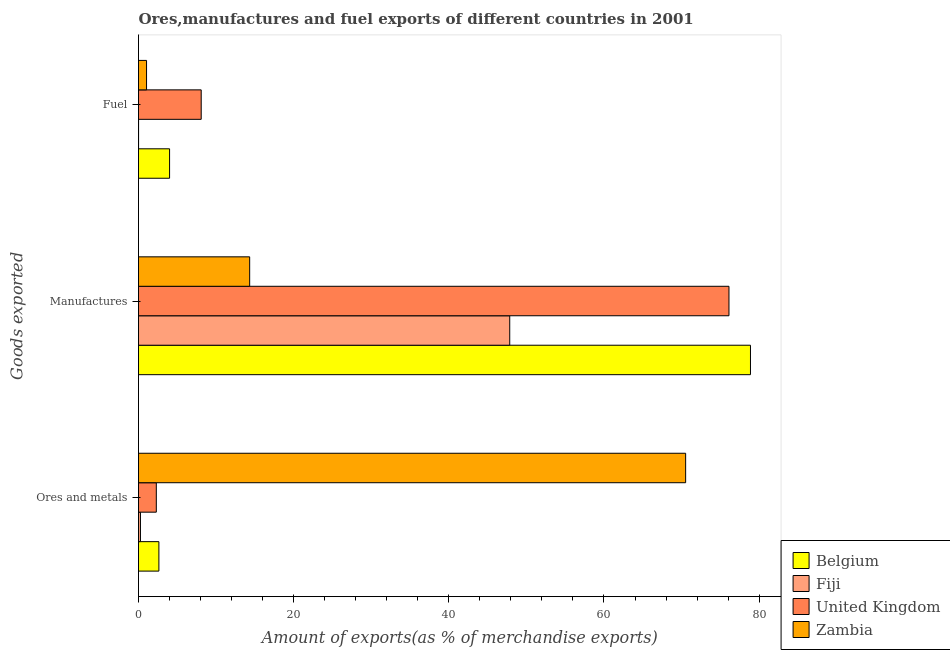How many bars are there on the 2nd tick from the bottom?
Your answer should be very brief. 4. What is the label of the 1st group of bars from the top?
Provide a succinct answer. Fuel. What is the percentage of fuel exports in Fiji?
Make the answer very short. 0.01. Across all countries, what is the maximum percentage of ores and metals exports?
Provide a succinct answer. 70.53. Across all countries, what is the minimum percentage of manufactures exports?
Offer a very short reply. 14.33. In which country was the percentage of manufactures exports minimum?
Ensure brevity in your answer.  Zambia. What is the total percentage of fuel exports in the graph?
Ensure brevity in your answer.  13.13. What is the difference between the percentage of fuel exports in United Kingdom and that in Zambia?
Keep it short and to the point. 7.04. What is the difference between the percentage of manufactures exports in Fiji and the percentage of ores and metals exports in United Kingdom?
Offer a terse response. 45.56. What is the average percentage of ores and metals exports per country?
Ensure brevity in your answer.  18.93. What is the difference between the percentage of manufactures exports and percentage of fuel exports in United Kingdom?
Give a very brief answer. 68.03. What is the ratio of the percentage of ores and metals exports in United Kingdom to that in Belgium?
Provide a short and direct response. 0.87. Is the percentage of ores and metals exports in United Kingdom less than that in Zambia?
Your answer should be very brief. Yes. Is the difference between the percentage of manufactures exports in Fiji and Zambia greater than the difference between the percentage of ores and metals exports in Fiji and Zambia?
Your answer should be very brief. Yes. What is the difference between the highest and the second highest percentage of fuel exports?
Offer a very short reply. 4.08. What is the difference between the highest and the lowest percentage of fuel exports?
Provide a short and direct response. 8.08. What does the 3rd bar from the bottom in Ores and metals represents?
Offer a very short reply. United Kingdom. Is it the case that in every country, the sum of the percentage of ores and metals exports and percentage of manufactures exports is greater than the percentage of fuel exports?
Make the answer very short. Yes. Are all the bars in the graph horizontal?
Make the answer very short. Yes. How many countries are there in the graph?
Your answer should be very brief. 4. Does the graph contain any zero values?
Offer a terse response. No. Does the graph contain grids?
Provide a succinct answer. No. How many legend labels are there?
Offer a terse response. 4. What is the title of the graph?
Make the answer very short. Ores,manufactures and fuel exports of different countries in 2001. Does "Spain" appear as one of the legend labels in the graph?
Ensure brevity in your answer.  No. What is the label or title of the X-axis?
Your response must be concise. Amount of exports(as % of merchandise exports). What is the label or title of the Y-axis?
Make the answer very short. Goods exported. What is the Amount of exports(as % of merchandise exports) of Belgium in Ores and metals?
Your answer should be compact. 2.63. What is the Amount of exports(as % of merchandise exports) in Fiji in Ores and metals?
Provide a short and direct response. 0.25. What is the Amount of exports(as % of merchandise exports) in United Kingdom in Ores and metals?
Offer a very short reply. 2.29. What is the Amount of exports(as % of merchandise exports) in Zambia in Ores and metals?
Your answer should be very brief. 70.53. What is the Amount of exports(as % of merchandise exports) of Belgium in Manufactures?
Your answer should be very brief. 78.88. What is the Amount of exports(as % of merchandise exports) in Fiji in Manufactures?
Your response must be concise. 47.85. What is the Amount of exports(as % of merchandise exports) in United Kingdom in Manufactures?
Ensure brevity in your answer.  76.11. What is the Amount of exports(as % of merchandise exports) in Zambia in Manufactures?
Ensure brevity in your answer.  14.33. What is the Amount of exports(as % of merchandise exports) in Belgium in Fuel?
Keep it short and to the point. 4.01. What is the Amount of exports(as % of merchandise exports) of Fiji in Fuel?
Provide a succinct answer. 0.01. What is the Amount of exports(as % of merchandise exports) of United Kingdom in Fuel?
Provide a short and direct response. 8.08. What is the Amount of exports(as % of merchandise exports) of Zambia in Fuel?
Ensure brevity in your answer.  1.04. Across all Goods exported, what is the maximum Amount of exports(as % of merchandise exports) in Belgium?
Offer a terse response. 78.88. Across all Goods exported, what is the maximum Amount of exports(as % of merchandise exports) in Fiji?
Offer a terse response. 47.85. Across all Goods exported, what is the maximum Amount of exports(as % of merchandise exports) of United Kingdom?
Provide a succinct answer. 76.11. Across all Goods exported, what is the maximum Amount of exports(as % of merchandise exports) in Zambia?
Provide a short and direct response. 70.53. Across all Goods exported, what is the minimum Amount of exports(as % of merchandise exports) in Belgium?
Make the answer very short. 2.63. Across all Goods exported, what is the minimum Amount of exports(as % of merchandise exports) in Fiji?
Your answer should be compact. 0.01. Across all Goods exported, what is the minimum Amount of exports(as % of merchandise exports) in United Kingdom?
Provide a succinct answer. 2.29. Across all Goods exported, what is the minimum Amount of exports(as % of merchandise exports) of Zambia?
Provide a succinct answer. 1.04. What is the total Amount of exports(as % of merchandise exports) of Belgium in the graph?
Offer a terse response. 85.52. What is the total Amount of exports(as % of merchandise exports) of Fiji in the graph?
Provide a succinct answer. 48.11. What is the total Amount of exports(as % of merchandise exports) in United Kingdom in the graph?
Keep it short and to the point. 86.49. What is the total Amount of exports(as % of merchandise exports) of Zambia in the graph?
Ensure brevity in your answer.  85.9. What is the difference between the Amount of exports(as % of merchandise exports) in Belgium in Ores and metals and that in Manufactures?
Ensure brevity in your answer.  -76.26. What is the difference between the Amount of exports(as % of merchandise exports) in Fiji in Ores and metals and that in Manufactures?
Provide a short and direct response. -47.6. What is the difference between the Amount of exports(as % of merchandise exports) in United Kingdom in Ores and metals and that in Manufactures?
Ensure brevity in your answer.  -73.82. What is the difference between the Amount of exports(as % of merchandise exports) in Zambia in Ores and metals and that in Manufactures?
Your answer should be very brief. 56.2. What is the difference between the Amount of exports(as % of merchandise exports) in Belgium in Ores and metals and that in Fuel?
Provide a short and direct response. -1.38. What is the difference between the Amount of exports(as % of merchandise exports) of Fiji in Ores and metals and that in Fuel?
Offer a very short reply. 0.24. What is the difference between the Amount of exports(as % of merchandise exports) of United Kingdom in Ores and metals and that in Fuel?
Make the answer very short. -5.79. What is the difference between the Amount of exports(as % of merchandise exports) of Zambia in Ores and metals and that in Fuel?
Ensure brevity in your answer.  69.49. What is the difference between the Amount of exports(as % of merchandise exports) of Belgium in Manufactures and that in Fuel?
Make the answer very short. 74.88. What is the difference between the Amount of exports(as % of merchandise exports) of Fiji in Manufactures and that in Fuel?
Offer a very short reply. 47.85. What is the difference between the Amount of exports(as % of merchandise exports) in United Kingdom in Manufactures and that in Fuel?
Provide a short and direct response. 68.03. What is the difference between the Amount of exports(as % of merchandise exports) of Zambia in Manufactures and that in Fuel?
Offer a very short reply. 13.29. What is the difference between the Amount of exports(as % of merchandise exports) in Belgium in Ores and metals and the Amount of exports(as % of merchandise exports) in Fiji in Manufactures?
Ensure brevity in your answer.  -45.23. What is the difference between the Amount of exports(as % of merchandise exports) of Belgium in Ores and metals and the Amount of exports(as % of merchandise exports) of United Kingdom in Manufactures?
Your response must be concise. -73.48. What is the difference between the Amount of exports(as % of merchandise exports) in Belgium in Ores and metals and the Amount of exports(as % of merchandise exports) in Zambia in Manufactures?
Keep it short and to the point. -11.7. What is the difference between the Amount of exports(as % of merchandise exports) of Fiji in Ores and metals and the Amount of exports(as % of merchandise exports) of United Kingdom in Manufactures?
Ensure brevity in your answer.  -75.86. What is the difference between the Amount of exports(as % of merchandise exports) in Fiji in Ores and metals and the Amount of exports(as % of merchandise exports) in Zambia in Manufactures?
Your response must be concise. -14.08. What is the difference between the Amount of exports(as % of merchandise exports) in United Kingdom in Ores and metals and the Amount of exports(as % of merchandise exports) in Zambia in Manufactures?
Your answer should be compact. -12.04. What is the difference between the Amount of exports(as % of merchandise exports) in Belgium in Ores and metals and the Amount of exports(as % of merchandise exports) in Fiji in Fuel?
Provide a succinct answer. 2.62. What is the difference between the Amount of exports(as % of merchandise exports) in Belgium in Ores and metals and the Amount of exports(as % of merchandise exports) in United Kingdom in Fuel?
Provide a short and direct response. -5.45. What is the difference between the Amount of exports(as % of merchandise exports) in Belgium in Ores and metals and the Amount of exports(as % of merchandise exports) in Zambia in Fuel?
Provide a succinct answer. 1.59. What is the difference between the Amount of exports(as % of merchandise exports) of Fiji in Ores and metals and the Amount of exports(as % of merchandise exports) of United Kingdom in Fuel?
Your response must be concise. -7.83. What is the difference between the Amount of exports(as % of merchandise exports) in Fiji in Ores and metals and the Amount of exports(as % of merchandise exports) in Zambia in Fuel?
Offer a terse response. -0.79. What is the difference between the Amount of exports(as % of merchandise exports) of United Kingdom in Ores and metals and the Amount of exports(as % of merchandise exports) of Zambia in Fuel?
Give a very brief answer. 1.26. What is the difference between the Amount of exports(as % of merchandise exports) in Belgium in Manufactures and the Amount of exports(as % of merchandise exports) in Fiji in Fuel?
Your response must be concise. 78.88. What is the difference between the Amount of exports(as % of merchandise exports) of Belgium in Manufactures and the Amount of exports(as % of merchandise exports) of United Kingdom in Fuel?
Your answer should be compact. 70.8. What is the difference between the Amount of exports(as % of merchandise exports) in Belgium in Manufactures and the Amount of exports(as % of merchandise exports) in Zambia in Fuel?
Make the answer very short. 77.85. What is the difference between the Amount of exports(as % of merchandise exports) of Fiji in Manufactures and the Amount of exports(as % of merchandise exports) of United Kingdom in Fuel?
Provide a succinct answer. 39.77. What is the difference between the Amount of exports(as % of merchandise exports) in Fiji in Manufactures and the Amount of exports(as % of merchandise exports) in Zambia in Fuel?
Your answer should be compact. 46.82. What is the difference between the Amount of exports(as % of merchandise exports) of United Kingdom in Manufactures and the Amount of exports(as % of merchandise exports) of Zambia in Fuel?
Offer a very short reply. 75.07. What is the average Amount of exports(as % of merchandise exports) of Belgium per Goods exported?
Provide a succinct answer. 28.51. What is the average Amount of exports(as % of merchandise exports) in Fiji per Goods exported?
Keep it short and to the point. 16.04. What is the average Amount of exports(as % of merchandise exports) of United Kingdom per Goods exported?
Your answer should be compact. 28.83. What is the average Amount of exports(as % of merchandise exports) of Zambia per Goods exported?
Provide a short and direct response. 28.63. What is the difference between the Amount of exports(as % of merchandise exports) of Belgium and Amount of exports(as % of merchandise exports) of Fiji in Ores and metals?
Keep it short and to the point. 2.38. What is the difference between the Amount of exports(as % of merchandise exports) in Belgium and Amount of exports(as % of merchandise exports) in United Kingdom in Ores and metals?
Give a very brief answer. 0.33. What is the difference between the Amount of exports(as % of merchandise exports) in Belgium and Amount of exports(as % of merchandise exports) in Zambia in Ores and metals?
Give a very brief answer. -67.9. What is the difference between the Amount of exports(as % of merchandise exports) in Fiji and Amount of exports(as % of merchandise exports) in United Kingdom in Ores and metals?
Provide a short and direct response. -2.04. What is the difference between the Amount of exports(as % of merchandise exports) of Fiji and Amount of exports(as % of merchandise exports) of Zambia in Ores and metals?
Your answer should be very brief. -70.28. What is the difference between the Amount of exports(as % of merchandise exports) of United Kingdom and Amount of exports(as % of merchandise exports) of Zambia in Ores and metals?
Keep it short and to the point. -68.23. What is the difference between the Amount of exports(as % of merchandise exports) of Belgium and Amount of exports(as % of merchandise exports) of Fiji in Manufactures?
Offer a very short reply. 31.03. What is the difference between the Amount of exports(as % of merchandise exports) of Belgium and Amount of exports(as % of merchandise exports) of United Kingdom in Manufactures?
Offer a very short reply. 2.77. What is the difference between the Amount of exports(as % of merchandise exports) in Belgium and Amount of exports(as % of merchandise exports) in Zambia in Manufactures?
Provide a short and direct response. 64.55. What is the difference between the Amount of exports(as % of merchandise exports) of Fiji and Amount of exports(as % of merchandise exports) of United Kingdom in Manufactures?
Make the answer very short. -28.26. What is the difference between the Amount of exports(as % of merchandise exports) of Fiji and Amount of exports(as % of merchandise exports) of Zambia in Manufactures?
Give a very brief answer. 33.52. What is the difference between the Amount of exports(as % of merchandise exports) of United Kingdom and Amount of exports(as % of merchandise exports) of Zambia in Manufactures?
Ensure brevity in your answer.  61.78. What is the difference between the Amount of exports(as % of merchandise exports) in Belgium and Amount of exports(as % of merchandise exports) in Fiji in Fuel?
Your answer should be very brief. 4. What is the difference between the Amount of exports(as % of merchandise exports) of Belgium and Amount of exports(as % of merchandise exports) of United Kingdom in Fuel?
Give a very brief answer. -4.08. What is the difference between the Amount of exports(as % of merchandise exports) of Belgium and Amount of exports(as % of merchandise exports) of Zambia in Fuel?
Your response must be concise. 2.97. What is the difference between the Amount of exports(as % of merchandise exports) in Fiji and Amount of exports(as % of merchandise exports) in United Kingdom in Fuel?
Provide a succinct answer. -8.08. What is the difference between the Amount of exports(as % of merchandise exports) in Fiji and Amount of exports(as % of merchandise exports) in Zambia in Fuel?
Provide a succinct answer. -1.03. What is the difference between the Amount of exports(as % of merchandise exports) in United Kingdom and Amount of exports(as % of merchandise exports) in Zambia in Fuel?
Give a very brief answer. 7.04. What is the ratio of the Amount of exports(as % of merchandise exports) of Fiji in Ores and metals to that in Manufactures?
Your response must be concise. 0.01. What is the ratio of the Amount of exports(as % of merchandise exports) of United Kingdom in Ores and metals to that in Manufactures?
Your answer should be compact. 0.03. What is the ratio of the Amount of exports(as % of merchandise exports) of Zambia in Ores and metals to that in Manufactures?
Your answer should be very brief. 4.92. What is the ratio of the Amount of exports(as % of merchandise exports) of Belgium in Ores and metals to that in Fuel?
Provide a short and direct response. 0.66. What is the ratio of the Amount of exports(as % of merchandise exports) of Fiji in Ores and metals to that in Fuel?
Your answer should be very brief. 41.43. What is the ratio of the Amount of exports(as % of merchandise exports) of United Kingdom in Ores and metals to that in Fuel?
Offer a very short reply. 0.28. What is the ratio of the Amount of exports(as % of merchandise exports) of Zambia in Ores and metals to that in Fuel?
Give a very brief answer. 68. What is the ratio of the Amount of exports(as % of merchandise exports) of Belgium in Manufactures to that in Fuel?
Offer a very short reply. 19.7. What is the ratio of the Amount of exports(as % of merchandise exports) in Fiji in Manufactures to that in Fuel?
Your answer should be very brief. 7916.29. What is the ratio of the Amount of exports(as % of merchandise exports) of United Kingdom in Manufactures to that in Fuel?
Give a very brief answer. 9.42. What is the ratio of the Amount of exports(as % of merchandise exports) in Zambia in Manufactures to that in Fuel?
Offer a terse response. 13.82. What is the difference between the highest and the second highest Amount of exports(as % of merchandise exports) in Belgium?
Offer a very short reply. 74.88. What is the difference between the highest and the second highest Amount of exports(as % of merchandise exports) of Fiji?
Provide a succinct answer. 47.6. What is the difference between the highest and the second highest Amount of exports(as % of merchandise exports) of United Kingdom?
Offer a terse response. 68.03. What is the difference between the highest and the second highest Amount of exports(as % of merchandise exports) of Zambia?
Offer a very short reply. 56.2. What is the difference between the highest and the lowest Amount of exports(as % of merchandise exports) in Belgium?
Your answer should be compact. 76.26. What is the difference between the highest and the lowest Amount of exports(as % of merchandise exports) of Fiji?
Your answer should be compact. 47.85. What is the difference between the highest and the lowest Amount of exports(as % of merchandise exports) in United Kingdom?
Provide a succinct answer. 73.82. What is the difference between the highest and the lowest Amount of exports(as % of merchandise exports) of Zambia?
Give a very brief answer. 69.49. 